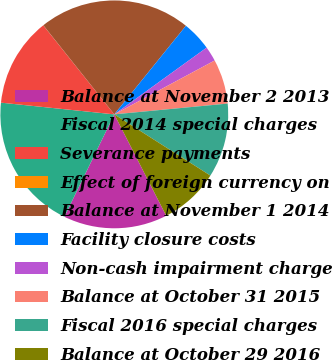Convert chart to OTSL. <chart><loc_0><loc_0><loc_500><loc_500><pie_chart><fcel>Balance at November 2 2013<fcel>Fiscal 2014 special charges<fcel>Severance payments<fcel>Effect of foreign currency on<fcel>Balance at November 1 2014<fcel>Facility closure costs<fcel>Non-cash impairment charge<fcel>Balance at October 31 2015<fcel>Fiscal 2016 special charges<fcel>Balance at October 29 2016<nl><fcel>14.76%<fcel>19.42%<fcel>12.65%<fcel>0.01%<fcel>21.53%<fcel>4.22%<fcel>2.12%<fcel>6.33%<fcel>10.54%<fcel>8.44%<nl></chart> 